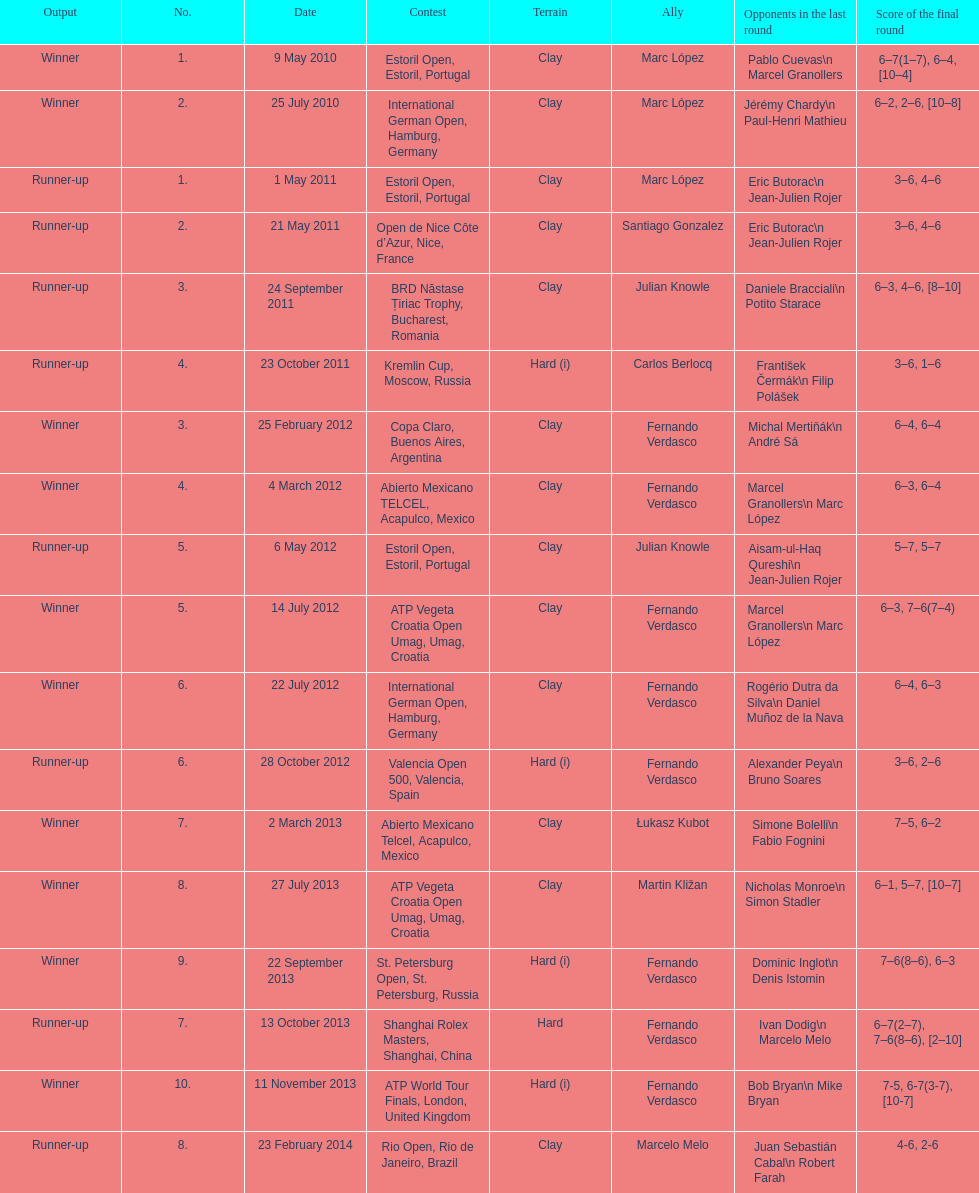What is the number of winning outcomes? 10. Write the full table. {'header': ['Output', 'No.', 'Date', 'Contest', 'Terrain', 'Ally', 'Opponents in the last round', 'Score of the final round'], 'rows': [['Winner', '1.', '9 May 2010', 'Estoril Open, Estoril, Portugal', 'Clay', 'Marc López', 'Pablo Cuevas\\n Marcel Granollers', '6–7(1–7), 6–4, [10–4]'], ['Winner', '2.', '25 July 2010', 'International German Open, Hamburg, Germany', 'Clay', 'Marc López', 'Jérémy Chardy\\n Paul-Henri Mathieu', '6–2, 2–6, [10–8]'], ['Runner-up', '1.', '1 May 2011', 'Estoril Open, Estoril, Portugal', 'Clay', 'Marc López', 'Eric Butorac\\n Jean-Julien Rojer', '3–6, 4–6'], ['Runner-up', '2.', '21 May 2011', 'Open de Nice Côte d’Azur, Nice, France', 'Clay', 'Santiago Gonzalez', 'Eric Butorac\\n Jean-Julien Rojer', '3–6, 4–6'], ['Runner-up', '3.', '24 September 2011', 'BRD Năstase Țiriac Trophy, Bucharest, Romania', 'Clay', 'Julian Knowle', 'Daniele Bracciali\\n Potito Starace', '6–3, 4–6, [8–10]'], ['Runner-up', '4.', '23 October 2011', 'Kremlin Cup, Moscow, Russia', 'Hard (i)', 'Carlos Berlocq', 'František Čermák\\n Filip Polášek', '3–6, 1–6'], ['Winner', '3.', '25 February 2012', 'Copa Claro, Buenos Aires, Argentina', 'Clay', 'Fernando Verdasco', 'Michal Mertiňák\\n André Sá', '6–4, 6–4'], ['Winner', '4.', '4 March 2012', 'Abierto Mexicano TELCEL, Acapulco, Mexico', 'Clay', 'Fernando Verdasco', 'Marcel Granollers\\n Marc López', '6–3, 6–4'], ['Runner-up', '5.', '6 May 2012', 'Estoril Open, Estoril, Portugal', 'Clay', 'Julian Knowle', 'Aisam-ul-Haq Qureshi\\n Jean-Julien Rojer', '5–7, 5–7'], ['Winner', '5.', '14 July 2012', 'ATP Vegeta Croatia Open Umag, Umag, Croatia', 'Clay', 'Fernando Verdasco', 'Marcel Granollers\\n Marc López', '6–3, 7–6(7–4)'], ['Winner', '6.', '22 July 2012', 'International German Open, Hamburg, Germany', 'Clay', 'Fernando Verdasco', 'Rogério Dutra da Silva\\n Daniel Muñoz de la Nava', '6–4, 6–3'], ['Runner-up', '6.', '28 October 2012', 'Valencia Open 500, Valencia, Spain', 'Hard (i)', 'Fernando Verdasco', 'Alexander Peya\\n Bruno Soares', '3–6, 2–6'], ['Winner', '7.', '2 March 2013', 'Abierto Mexicano Telcel, Acapulco, Mexico', 'Clay', 'Łukasz Kubot', 'Simone Bolelli\\n Fabio Fognini', '7–5, 6–2'], ['Winner', '8.', '27 July 2013', 'ATP Vegeta Croatia Open Umag, Umag, Croatia', 'Clay', 'Martin Kližan', 'Nicholas Monroe\\n Simon Stadler', '6–1, 5–7, [10–7]'], ['Winner', '9.', '22 September 2013', 'St. Petersburg Open, St. Petersburg, Russia', 'Hard (i)', 'Fernando Verdasco', 'Dominic Inglot\\n Denis Istomin', '7–6(8–6), 6–3'], ['Runner-up', '7.', '13 October 2013', 'Shanghai Rolex Masters, Shanghai, China', 'Hard', 'Fernando Verdasco', 'Ivan Dodig\\n Marcelo Melo', '6–7(2–7), 7–6(8–6), [2–10]'], ['Winner', '10.', '11 November 2013', 'ATP World Tour Finals, London, United Kingdom', 'Hard (i)', 'Fernando Verdasco', 'Bob Bryan\\n Mike Bryan', '7-5, 6-7(3-7), [10-7]'], ['Runner-up', '8.', '23 February 2014', 'Rio Open, Rio de Janeiro, Brazil', 'Clay', 'Marcelo Melo', 'Juan Sebastián Cabal\\n Robert Farah', '4-6, 2-6']]} 